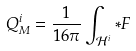Convert formula to latex. <formula><loc_0><loc_0><loc_500><loc_500>Q ^ { i } _ { M } = \frac { 1 } { 1 6 \pi } \int _ { \mathcal { H } ^ { i } } * F</formula> 